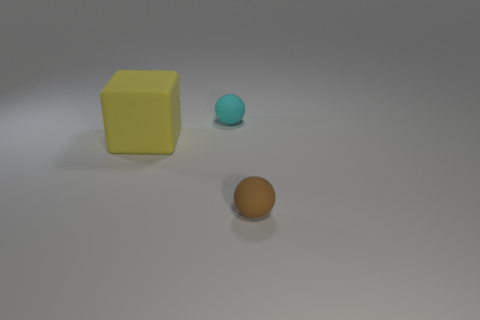Are there any other things that are the same size as the rubber cube?
Keep it short and to the point. No. Are there any cyan spheres that have the same size as the block?
Ensure brevity in your answer.  No. Do the object in front of the block and the yellow rubber cube have the same size?
Ensure brevity in your answer.  No. Are there more small brown matte balls than blue shiny spheres?
Offer a terse response. Yes. Are there any big yellow matte things of the same shape as the small brown thing?
Your response must be concise. No. What shape is the tiny brown object in front of the yellow matte cube?
Give a very brief answer. Sphere. How many cyan things are left of the small thing that is right of the tiny rubber object behind the big matte block?
Your answer should be very brief. 1. There is a small rubber object in front of the small cyan sphere; does it have the same color as the large object?
Keep it short and to the point. No. What number of other things are the same shape as the yellow object?
Your answer should be compact. 0. How many other things are there of the same material as the small cyan ball?
Ensure brevity in your answer.  2. 